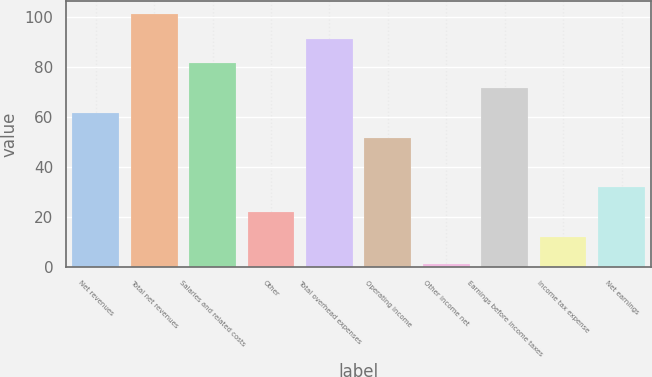<chart> <loc_0><loc_0><loc_500><loc_500><bar_chart><fcel>Net revenues<fcel>Total net revenues<fcel>Salaries and related costs<fcel>Other<fcel>Total overhead expenses<fcel>Operating income<fcel>Other income net<fcel>Earnings before income taxes<fcel>Income tax expense<fcel>Net earnings<nl><fcel>61.5<fcel>101.1<fcel>81.3<fcel>21.9<fcel>91.2<fcel>51.6<fcel>1<fcel>71.4<fcel>12<fcel>31.8<nl></chart> 